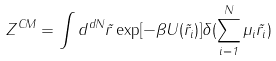Convert formula to latex. <formula><loc_0><loc_0><loc_500><loc_500>Z ^ { C M } = \int d ^ { d N } \vec { r } \exp [ - \beta U ( \vec { r } _ { i } ) ] \delta ( \sum _ { i = 1 } ^ { N } \mu _ { i } \vec { r } _ { i } )</formula> 